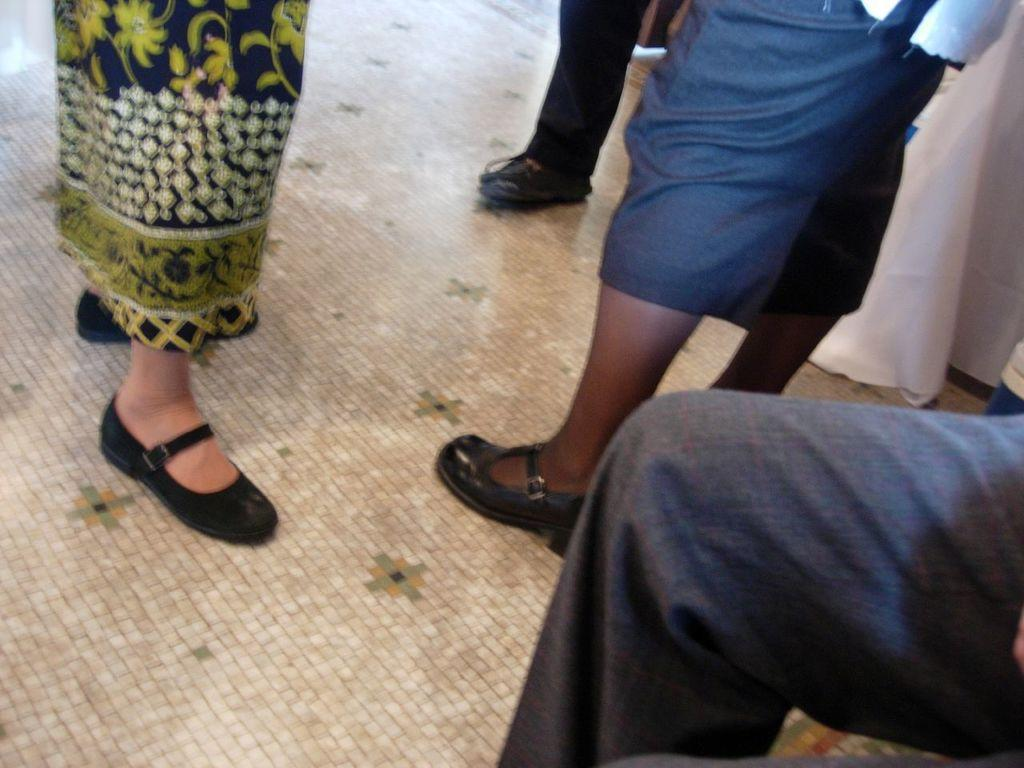What body parts are visible in the image? There are persons' legs visible in the image. What are the legs wearing? There are shoes visible in the image. Where are the legs and shoes located? Both legs and shoes are on the floor. What type of hair can be seen on the writer's head in the image? There is no writer or hair present in the image; it only features legs and shoes on the floor. 